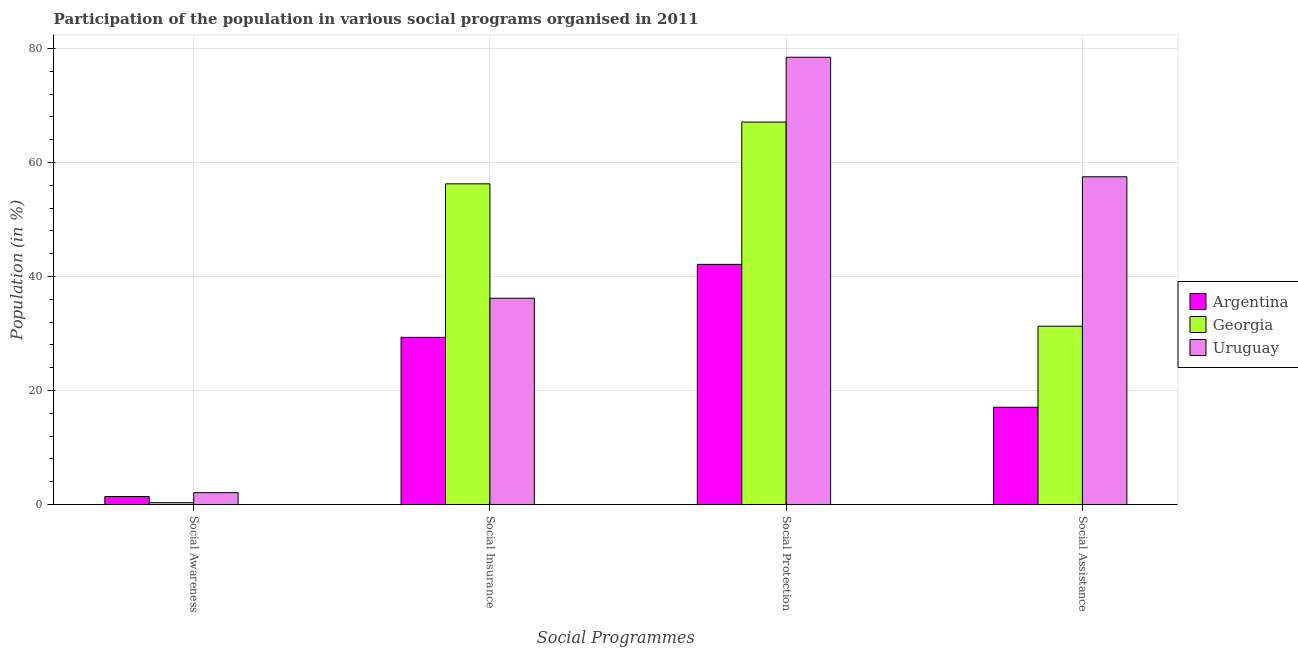Are the number of bars per tick equal to the number of legend labels?
Ensure brevity in your answer.  Yes. How many bars are there on the 4th tick from the left?
Keep it short and to the point. 3. How many bars are there on the 1st tick from the right?
Provide a succinct answer. 3. What is the label of the 1st group of bars from the left?
Ensure brevity in your answer.  Social Awareness. What is the participation of population in social awareness programs in Georgia?
Ensure brevity in your answer.  0.33. Across all countries, what is the maximum participation of population in social insurance programs?
Give a very brief answer. 56.27. Across all countries, what is the minimum participation of population in social protection programs?
Give a very brief answer. 42.14. In which country was the participation of population in social insurance programs maximum?
Keep it short and to the point. Georgia. In which country was the participation of population in social insurance programs minimum?
Offer a terse response. Argentina. What is the total participation of population in social insurance programs in the graph?
Offer a terse response. 121.79. What is the difference between the participation of population in social insurance programs in Georgia and that in Uruguay?
Provide a short and direct response. 20.07. What is the difference between the participation of population in social protection programs in Argentina and the participation of population in social awareness programs in Uruguay?
Ensure brevity in your answer.  40.06. What is the average participation of population in social awareness programs per country?
Keep it short and to the point. 1.27. What is the difference between the participation of population in social awareness programs and participation of population in social insurance programs in Uruguay?
Your answer should be very brief. -34.11. What is the ratio of the participation of population in social awareness programs in Uruguay to that in Argentina?
Make the answer very short. 1.48. Is the participation of population in social assistance programs in Uruguay less than that in Georgia?
Offer a terse response. No. What is the difference between the highest and the second highest participation of population in social protection programs?
Provide a succinct answer. 11.37. What is the difference between the highest and the lowest participation of population in social assistance programs?
Give a very brief answer. 40.44. Is the sum of the participation of population in social awareness programs in Argentina and Uruguay greater than the maximum participation of population in social assistance programs across all countries?
Keep it short and to the point. No. What does the 3rd bar from the left in Social Assistance represents?
Provide a succinct answer. Uruguay. What does the 2nd bar from the right in Social Protection represents?
Your answer should be compact. Georgia. How many countries are there in the graph?
Make the answer very short. 3. What is the difference between two consecutive major ticks on the Y-axis?
Ensure brevity in your answer.  20. Where does the legend appear in the graph?
Provide a succinct answer. Center right. How many legend labels are there?
Offer a terse response. 3. How are the legend labels stacked?
Provide a succinct answer. Vertical. What is the title of the graph?
Offer a very short reply. Participation of the population in various social programs organised in 2011. Does "Hungary" appear as one of the legend labels in the graph?
Offer a terse response. No. What is the label or title of the X-axis?
Provide a succinct answer. Social Programmes. What is the label or title of the Y-axis?
Offer a very short reply. Population (in %). What is the Population (in %) of Argentina in Social Awareness?
Give a very brief answer. 1.4. What is the Population (in %) of Georgia in Social Awareness?
Provide a short and direct response. 0.33. What is the Population (in %) in Uruguay in Social Awareness?
Your answer should be very brief. 2.08. What is the Population (in %) in Argentina in Social Insurance?
Make the answer very short. 29.33. What is the Population (in %) in Georgia in Social Insurance?
Ensure brevity in your answer.  56.27. What is the Population (in %) of Uruguay in Social Insurance?
Offer a very short reply. 36.19. What is the Population (in %) in Argentina in Social Protection?
Your answer should be compact. 42.14. What is the Population (in %) of Georgia in Social Protection?
Keep it short and to the point. 67.11. What is the Population (in %) in Uruguay in Social Protection?
Your answer should be compact. 78.48. What is the Population (in %) of Argentina in Social Assistance?
Ensure brevity in your answer.  17.06. What is the Population (in %) in Georgia in Social Assistance?
Provide a succinct answer. 31.29. What is the Population (in %) of Uruguay in Social Assistance?
Provide a short and direct response. 57.51. Across all Social Programmes, what is the maximum Population (in %) in Argentina?
Offer a terse response. 42.14. Across all Social Programmes, what is the maximum Population (in %) in Georgia?
Your answer should be very brief. 67.11. Across all Social Programmes, what is the maximum Population (in %) of Uruguay?
Your response must be concise. 78.48. Across all Social Programmes, what is the minimum Population (in %) in Argentina?
Your response must be concise. 1.4. Across all Social Programmes, what is the minimum Population (in %) in Georgia?
Make the answer very short. 0.33. Across all Social Programmes, what is the minimum Population (in %) in Uruguay?
Offer a very short reply. 2.08. What is the total Population (in %) of Argentina in the graph?
Keep it short and to the point. 89.94. What is the total Population (in %) of Georgia in the graph?
Provide a short and direct response. 154.98. What is the total Population (in %) of Uruguay in the graph?
Your answer should be very brief. 174.26. What is the difference between the Population (in %) of Argentina in Social Awareness and that in Social Insurance?
Your response must be concise. -27.93. What is the difference between the Population (in %) of Georgia in Social Awareness and that in Social Insurance?
Keep it short and to the point. -55.94. What is the difference between the Population (in %) of Uruguay in Social Awareness and that in Social Insurance?
Your answer should be compact. -34.11. What is the difference between the Population (in %) of Argentina in Social Awareness and that in Social Protection?
Give a very brief answer. -40.73. What is the difference between the Population (in %) of Georgia in Social Awareness and that in Social Protection?
Your answer should be very brief. -66.78. What is the difference between the Population (in %) in Uruguay in Social Awareness and that in Social Protection?
Your response must be concise. -76.4. What is the difference between the Population (in %) of Argentina in Social Awareness and that in Social Assistance?
Ensure brevity in your answer.  -15.66. What is the difference between the Population (in %) in Georgia in Social Awareness and that in Social Assistance?
Offer a very short reply. -30.96. What is the difference between the Population (in %) in Uruguay in Social Awareness and that in Social Assistance?
Make the answer very short. -55.43. What is the difference between the Population (in %) in Argentina in Social Insurance and that in Social Protection?
Your response must be concise. -12.81. What is the difference between the Population (in %) in Georgia in Social Insurance and that in Social Protection?
Ensure brevity in your answer.  -10.84. What is the difference between the Population (in %) in Uruguay in Social Insurance and that in Social Protection?
Keep it short and to the point. -42.28. What is the difference between the Population (in %) of Argentina in Social Insurance and that in Social Assistance?
Your response must be concise. 12.27. What is the difference between the Population (in %) in Georgia in Social Insurance and that in Social Assistance?
Make the answer very short. 24.98. What is the difference between the Population (in %) of Uruguay in Social Insurance and that in Social Assistance?
Give a very brief answer. -21.31. What is the difference between the Population (in %) of Argentina in Social Protection and that in Social Assistance?
Your answer should be compact. 25.07. What is the difference between the Population (in %) in Georgia in Social Protection and that in Social Assistance?
Offer a very short reply. 35.82. What is the difference between the Population (in %) of Uruguay in Social Protection and that in Social Assistance?
Ensure brevity in your answer.  20.97. What is the difference between the Population (in %) of Argentina in Social Awareness and the Population (in %) of Georgia in Social Insurance?
Ensure brevity in your answer.  -54.86. What is the difference between the Population (in %) in Argentina in Social Awareness and the Population (in %) in Uruguay in Social Insurance?
Keep it short and to the point. -34.79. What is the difference between the Population (in %) in Georgia in Social Awareness and the Population (in %) in Uruguay in Social Insurance?
Your answer should be compact. -35.87. What is the difference between the Population (in %) in Argentina in Social Awareness and the Population (in %) in Georgia in Social Protection?
Provide a short and direct response. -65.7. What is the difference between the Population (in %) in Argentina in Social Awareness and the Population (in %) in Uruguay in Social Protection?
Provide a succinct answer. -77.07. What is the difference between the Population (in %) of Georgia in Social Awareness and the Population (in %) of Uruguay in Social Protection?
Keep it short and to the point. -78.15. What is the difference between the Population (in %) of Argentina in Social Awareness and the Population (in %) of Georgia in Social Assistance?
Your answer should be compact. -29.88. What is the difference between the Population (in %) in Argentina in Social Awareness and the Population (in %) in Uruguay in Social Assistance?
Your answer should be very brief. -56.1. What is the difference between the Population (in %) of Georgia in Social Awareness and the Population (in %) of Uruguay in Social Assistance?
Provide a succinct answer. -57.18. What is the difference between the Population (in %) of Argentina in Social Insurance and the Population (in %) of Georgia in Social Protection?
Provide a succinct answer. -37.77. What is the difference between the Population (in %) in Argentina in Social Insurance and the Population (in %) in Uruguay in Social Protection?
Offer a terse response. -49.15. What is the difference between the Population (in %) of Georgia in Social Insurance and the Population (in %) of Uruguay in Social Protection?
Provide a succinct answer. -22.21. What is the difference between the Population (in %) in Argentina in Social Insurance and the Population (in %) in Georgia in Social Assistance?
Offer a terse response. -1.95. What is the difference between the Population (in %) of Argentina in Social Insurance and the Population (in %) of Uruguay in Social Assistance?
Provide a succinct answer. -28.18. What is the difference between the Population (in %) in Georgia in Social Insurance and the Population (in %) in Uruguay in Social Assistance?
Give a very brief answer. -1.24. What is the difference between the Population (in %) in Argentina in Social Protection and the Population (in %) in Georgia in Social Assistance?
Make the answer very short. 10.85. What is the difference between the Population (in %) of Argentina in Social Protection and the Population (in %) of Uruguay in Social Assistance?
Offer a very short reply. -15.37. What is the difference between the Population (in %) in Georgia in Social Protection and the Population (in %) in Uruguay in Social Assistance?
Your response must be concise. 9.6. What is the average Population (in %) in Argentina per Social Programmes?
Ensure brevity in your answer.  22.48. What is the average Population (in %) in Georgia per Social Programmes?
Keep it short and to the point. 38.75. What is the average Population (in %) of Uruguay per Social Programmes?
Ensure brevity in your answer.  43.57. What is the difference between the Population (in %) in Argentina and Population (in %) in Georgia in Social Awareness?
Provide a succinct answer. 1.08. What is the difference between the Population (in %) of Argentina and Population (in %) of Uruguay in Social Awareness?
Offer a very short reply. -0.68. What is the difference between the Population (in %) of Georgia and Population (in %) of Uruguay in Social Awareness?
Offer a very short reply. -1.76. What is the difference between the Population (in %) of Argentina and Population (in %) of Georgia in Social Insurance?
Your response must be concise. -26.93. What is the difference between the Population (in %) of Argentina and Population (in %) of Uruguay in Social Insurance?
Provide a succinct answer. -6.86. What is the difference between the Population (in %) of Georgia and Population (in %) of Uruguay in Social Insurance?
Ensure brevity in your answer.  20.07. What is the difference between the Population (in %) in Argentina and Population (in %) in Georgia in Social Protection?
Provide a short and direct response. -24.97. What is the difference between the Population (in %) in Argentina and Population (in %) in Uruguay in Social Protection?
Provide a short and direct response. -36.34. What is the difference between the Population (in %) in Georgia and Population (in %) in Uruguay in Social Protection?
Your response must be concise. -11.37. What is the difference between the Population (in %) of Argentina and Population (in %) of Georgia in Social Assistance?
Offer a terse response. -14.22. What is the difference between the Population (in %) in Argentina and Population (in %) in Uruguay in Social Assistance?
Your answer should be very brief. -40.44. What is the difference between the Population (in %) in Georgia and Population (in %) in Uruguay in Social Assistance?
Keep it short and to the point. -26.22. What is the ratio of the Population (in %) of Argentina in Social Awareness to that in Social Insurance?
Keep it short and to the point. 0.05. What is the ratio of the Population (in %) in Georgia in Social Awareness to that in Social Insurance?
Ensure brevity in your answer.  0.01. What is the ratio of the Population (in %) in Uruguay in Social Awareness to that in Social Insurance?
Your response must be concise. 0.06. What is the ratio of the Population (in %) of Georgia in Social Awareness to that in Social Protection?
Your answer should be very brief. 0. What is the ratio of the Population (in %) in Uruguay in Social Awareness to that in Social Protection?
Your answer should be very brief. 0.03. What is the ratio of the Population (in %) in Argentina in Social Awareness to that in Social Assistance?
Keep it short and to the point. 0.08. What is the ratio of the Population (in %) of Georgia in Social Awareness to that in Social Assistance?
Give a very brief answer. 0.01. What is the ratio of the Population (in %) of Uruguay in Social Awareness to that in Social Assistance?
Ensure brevity in your answer.  0.04. What is the ratio of the Population (in %) of Argentina in Social Insurance to that in Social Protection?
Your answer should be compact. 0.7. What is the ratio of the Population (in %) of Georgia in Social Insurance to that in Social Protection?
Provide a short and direct response. 0.84. What is the ratio of the Population (in %) in Uruguay in Social Insurance to that in Social Protection?
Your answer should be compact. 0.46. What is the ratio of the Population (in %) in Argentina in Social Insurance to that in Social Assistance?
Your response must be concise. 1.72. What is the ratio of the Population (in %) in Georgia in Social Insurance to that in Social Assistance?
Keep it short and to the point. 1.8. What is the ratio of the Population (in %) in Uruguay in Social Insurance to that in Social Assistance?
Provide a succinct answer. 0.63. What is the ratio of the Population (in %) in Argentina in Social Protection to that in Social Assistance?
Keep it short and to the point. 2.47. What is the ratio of the Population (in %) in Georgia in Social Protection to that in Social Assistance?
Your answer should be very brief. 2.14. What is the ratio of the Population (in %) of Uruguay in Social Protection to that in Social Assistance?
Offer a terse response. 1.36. What is the difference between the highest and the second highest Population (in %) in Argentina?
Your answer should be compact. 12.81. What is the difference between the highest and the second highest Population (in %) in Georgia?
Keep it short and to the point. 10.84. What is the difference between the highest and the second highest Population (in %) in Uruguay?
Make the answer very short. 20.97. What is the difference between the highest and the lowest Population (in %) of Argentina?
Ensure brevity in your answer.  40.73. What is the difference between the highest and the lowest Population (in %) of Georgia?
Your response must be concise. 66.78. What is the difference between the highest and the lowest Population (in %) in Uruguay?
Offer a very short reply. 76.4. 